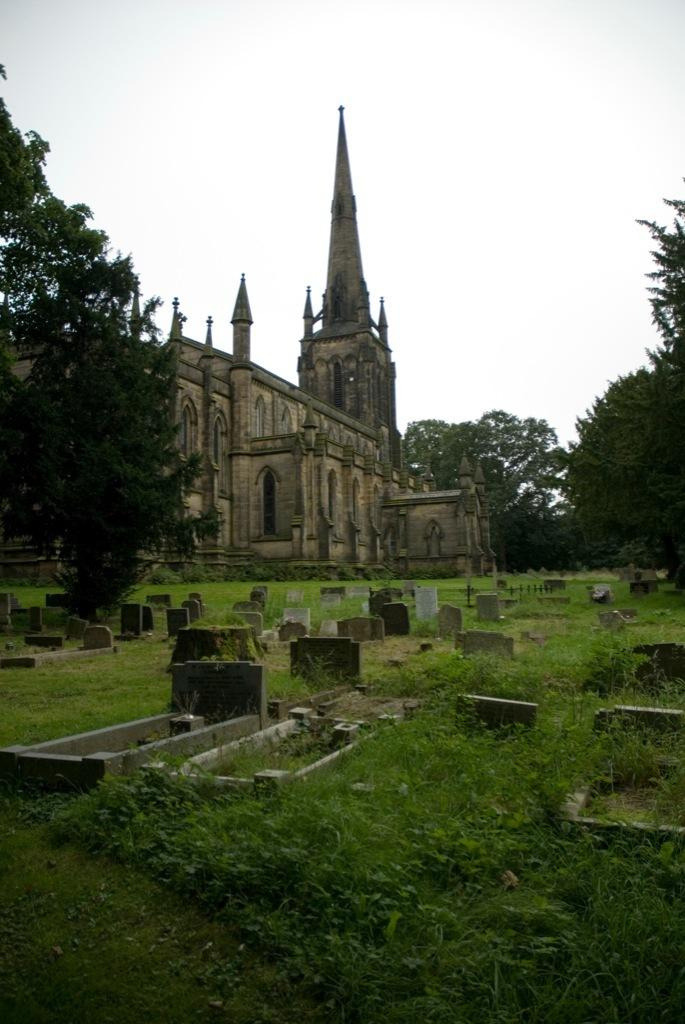What type of location is depicted in the image? The image contains cemeteries. What type of vegetation can be seen in the image? There is grass and trees in the image. What type of structure is present in the image? There is a building and a tower in the image. What is visible in the background of the image? The sky is visible in the image. Based on the presence of sunlight, when do you think the image was taken? The image was likely taken during the day. What caption would best describe the image? There is no caption provided with the image, so it is impossible to determine the best caption. Can you tell me how many friends are visible in the image? There are no people, including friends, present in the image. 